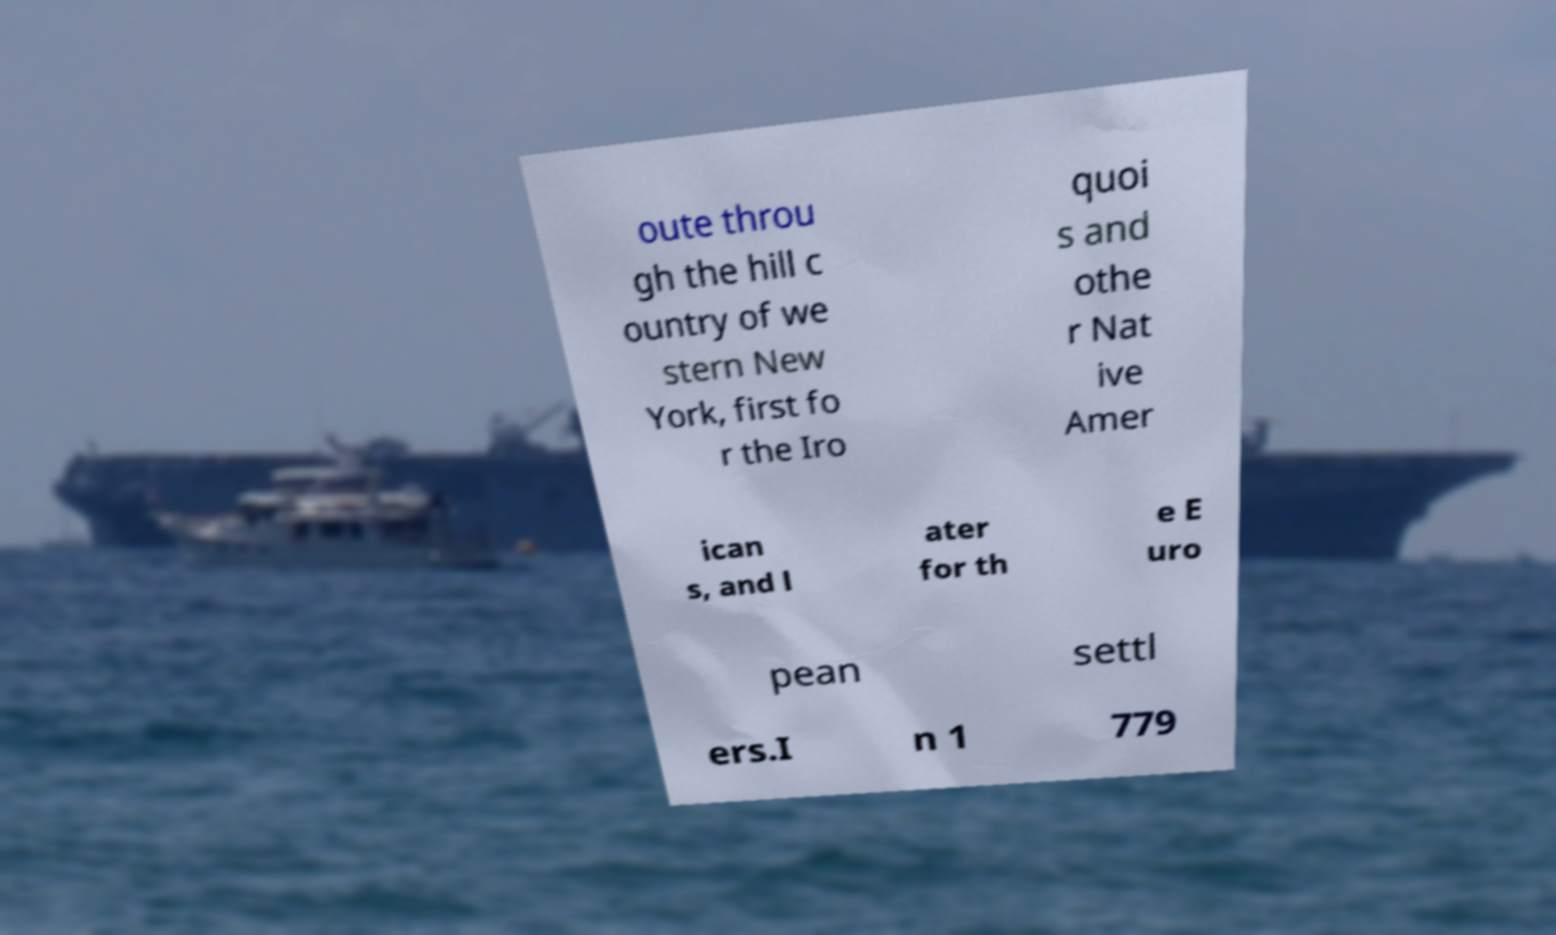What messages or text are displayed in this image? I need them in a readable, typed format. oute throu gh the hill c ountry of we stern New York, first fo r the Iro quoi s and othe r Nat ive Amer ican s, and l ater for th e E uro pean settl ers.I n 1 779 